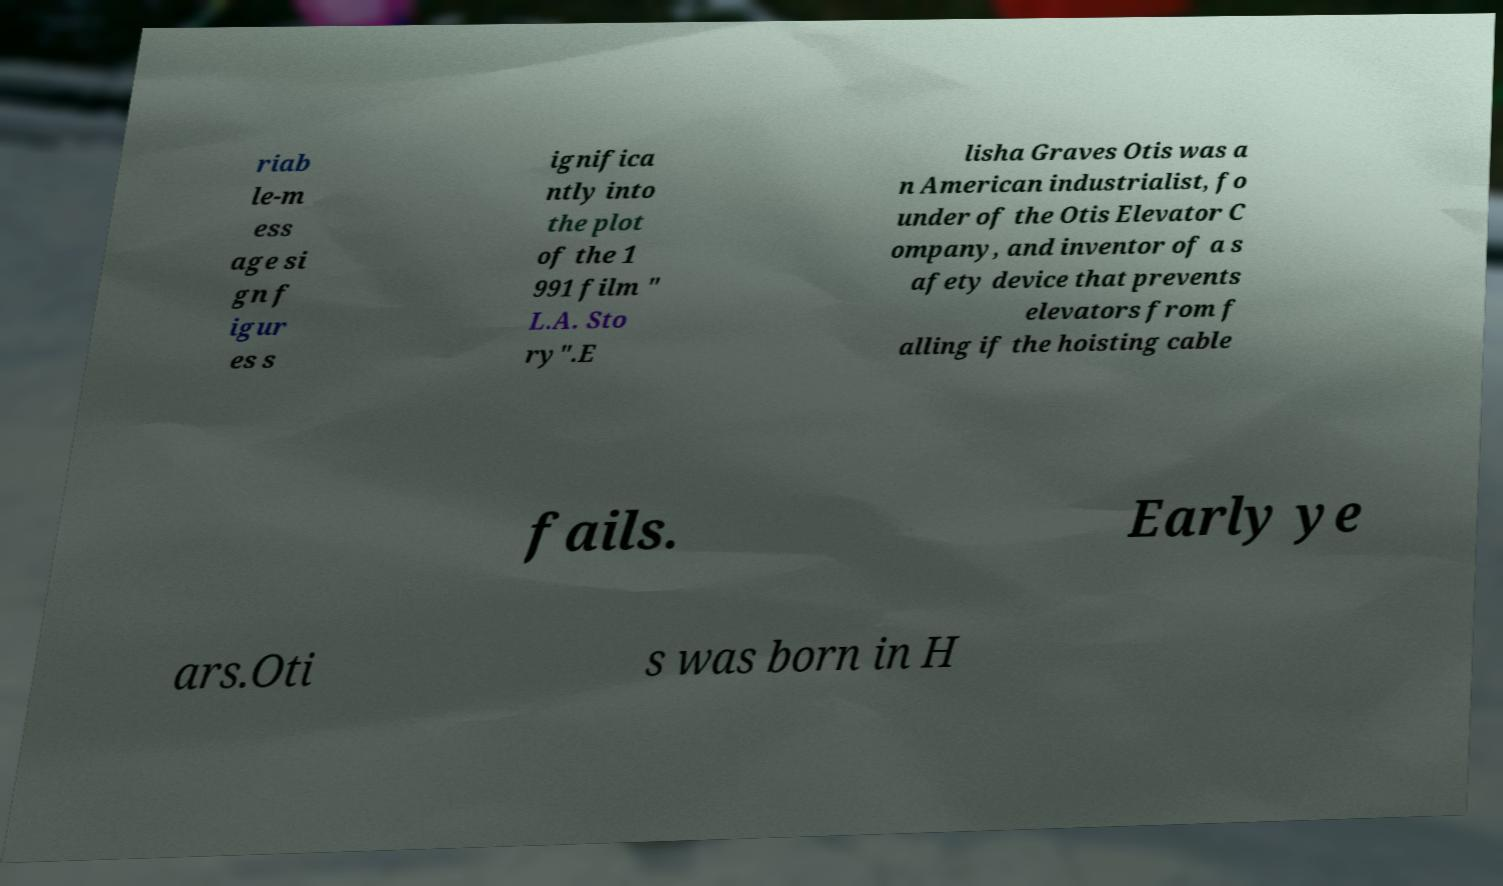Could you extract and type out the text from this image? riab le-m ess age si gn f igur es s ignifica ntly into the plot of the 1 991 film " L.A. Sto ry".E lisha Graves Otis was a n American industrialist, fo under of the Otis Elevator C ompany, and inventor of a s afety device that prevents elevators from f alling if the hoisting cable fails. Early ye ars.Oti s was born in H 